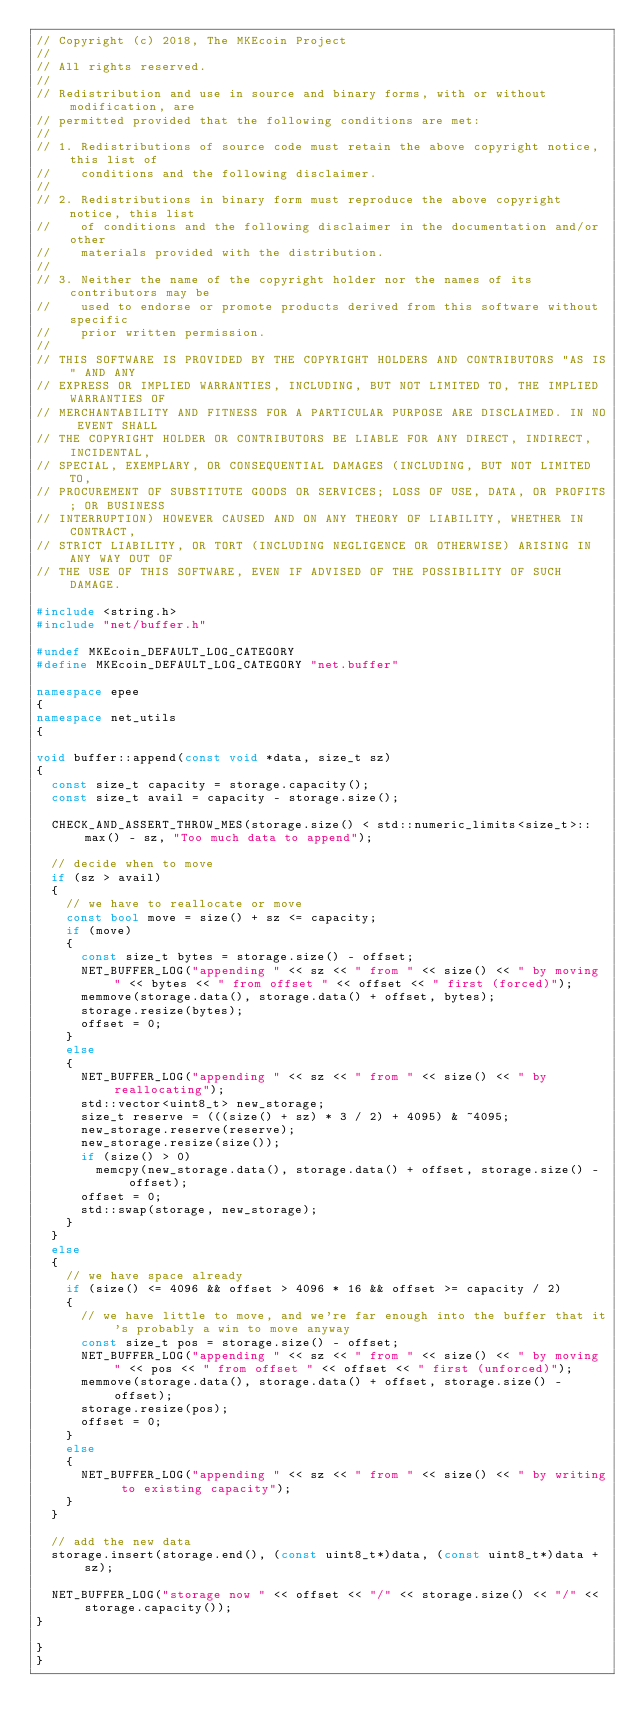Convert code to text. <code><loc_0><loc_0><loc_500><loc_500><_C++_>// Copyright (c) 2018, The MKEcoin Project
// 
// All rights reserved.
// 
// Redistribution and use in source and binary forms, with or without modification, are
// permitted provided that the following conditions are met:
// 
// 1. Redistributions of source code must retain the above copyright notice, this list of
//    conditions and the following disclaimer.
// 
// 2. Redistributions in binary form must reproduce the above copyright notice, this list
//    of conditions and the following disclaimer in the documentation and/or other
//    materials provided with the distribution.
// 
// 3. Neither the name of the copyright holder nor the names of its contributors may be
//    used to endorse or promote products derived from this software without specific
//    prior written permission.
// 
// THIS SOFTWARE IS PROVIDED BY THE COPYRIGHT HOLDERS AND CONTRIBUTORS "AS IS" AND ANY
// EXPRESS OR IMPLIED WARRANTIES, INCLUDING, BUT NOT LIMITED TO, THE IMPLIED WARRANTIES OF
// MERCHANTABILITY AND FITNESS FOR A PARTICULAR PURPOSE ARE DISCLAIMED. IN NO EVENT SHALL
// THE COPYRIGHT HOLDER OR CONTRIBUTORS BE LIABLE FOR ANY DIRECT, INDIRECT, INCIDENTAL,
// SPECIAL, EXEMPLARY, OR CONSEQUENTIAL DAMAGES (INCLUDING, BUT NOT LIMITED TO,
// PROCUREMENT OF SUBSTITUTE GOODS OR SERVICES; LOSS OF USE, DATA, OR PROFITS; OR BUSINESS
// INTERRUPTION) HOWEVER CAUSED AND ON ANY THEORY OF LIABILITY, WHETHER IN CONTRACT,
// STRICT LIABILITY, OR TORT (INCLUDING NEGLIGENCE OR OTHERWISE) ARISING IN ANY WAY OUT OF
// THE USE OF THIS SOFTWARE, EVEN IF ADVISED OF THE POSSIBILITY OF SUCH DAMAGE.

#include <string.h>
#include "net/buffer.h"

#undef MKEcoin_DEFAULT_LOG_CATEGORY
#define MKEcoin_DEFAULT_LOG_CATEGORY "net.buffer"

namespace epee
{
namespace net_utils
{

void buffer::append(const void *data, size_t sz)
{
  const size_t capacity = storage.capacity();
  const size_t avail = capacity - storage.size();

  CHECK_AND_ASSERT_THROW_MES(storage.size() < std::numeric_limits<size_t>::max() - sz, "Too much data to append");

  // decide when to move
  if (sz > avail)
  {
    // we have to reallocate or move
    const bool move = size() + sz <= capacity;
    if (move)
    {
      const size_t bytes = storage.size() - offset;
      NET_BUFFER_LOG("appending " << sz << " from " << size() << " by moving " << bytes << " from offset " << offset << " first (forced)");
      memmove(storage.data(), storage.data() + offset, bytes);
      storage.resize(bytes);
      offset = 0;
    }
    else
    {
      NET_BUFFER_LOG("appending " << sz << " from " << size() << " by reallocating");
      std::vector<uint8_t> new_storage;
      size_t reserve = (((size() + sz) * 3 / 2) + 4095) & ~4095;
      new_storage.reserve(reserve);
      new_storage.resize(size());
      if (size() > 0)
        memcpy(new_storage.data(), storage.data() + offset, storage.size() - offset);
      offset = 0;
      std::swap(storage, new_storage);
    }
  }
  else
  {
    // we have space already
    if (size() <= 4096 && offset > 4096 * 16 && offset >= capacity / 2)
    {
      // we have little to move, and we're far enough into the buffer that it's probably a win to move anyway
      const size_t pos = storage.size() - offset;
      NET_BUFFER_LOG("appending " << sz << " from " << size() << " by moving " << pos << " from offset " << offset << " first (unforced)");
      memmove(storage.data(), storage.data() + offset, storage.size() - offset);
      storage.resize(pos);
      offset = 0;
    }
    else
    {
      NET_BUFFER_LOG("appending " << sz << " from " << size() << " by writing to existing capacity");
    }
  }

  // add the new data
  storage.insert(storage.end(), (const uint8_t*)data, (const uint8_t*)data + sz);

  NET_BUFFER_LOG("storage now " << offset << "/" << storage.size() << "/" << storage.capacity());
}

}
}
</code> 